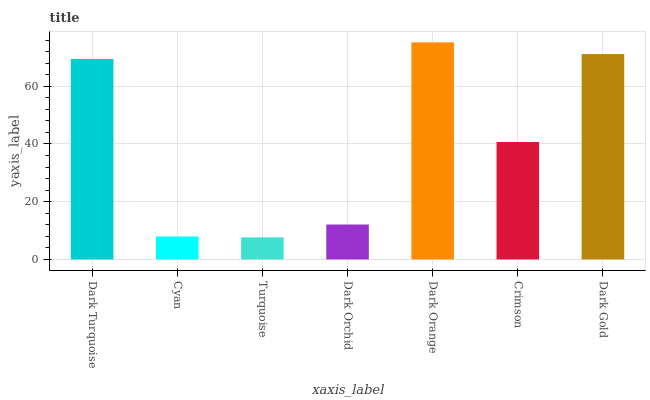Is Turquoise the minimum?
Answer yes or no. Yes. Is Dark Orange the maximum?
Answer yes or no. Yes. Is Cyan the minimum?
Answer yes or no. No. Is Cyan the maximum?
Answer yes or no. No. Is Dark Turquoise greater than Cyan?
Answer yes or no. Yes. Is Cyan less than Dark Turquoise?
Answer yes or no. Yes. Is Cyan greater than Dark Turquoise?
Answer yes or no. No. Is Dark Turquoise less than Cyan?
Answer yes or no. No. Is Crimson the high median?
Answer yes or no. Yes. Is Crimson the low median?
Answer yes or no. Yes. Is Dark Orange the high median?
Answer yes or no. No. Is Dark Gold the low median?
Answer yes or no. No. 